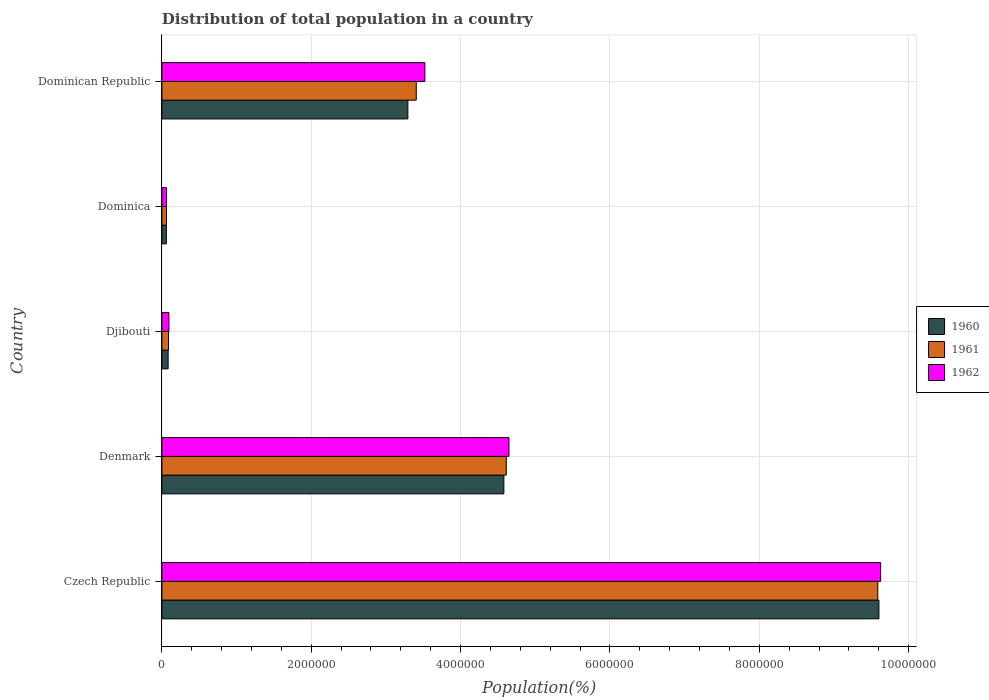How many groups of bars are there?
Give a very brief answer. 5. How many bars are there on the 3rd tick from the top?
Offer a very short reply. 3. How many bars are there on the 3rd tick from the bottom?
Offer a terse response. 3. What is the label of the 2nd group of bars from the top?
Provide a succinct answer. Dominica. What is the population of in 1962 in Czech Republic?
Your answer should be compact. 9.62e+06. Across all countries, what is the maximum population of in 1960?
Provide a succinct answer. 9.60e+06. Across all countries, what is the minimum population of in 1961?
Provide a short and direct response. 6.10e+04. In which country was the population of in 1962 maximum?
Give a very brief answer. Czech Republic. In which country was the population of in 1960 minimum?
Offer a terse response. Dominica. What is the total population of in 1961 in the graph?
Give a very brief answer. 1.78e+07. What is the difference between the population of in 1962 in Denmark and that in Dominican Republic?
Keep it short and to the point. 1.13e+06. What is the difference between the population of in 1962 in Djibouti and the population of in 1960 in Dominican Republic?
Keep it short and to the point. -3.20e+06. What is the average population of in 1962 per country?
Your response must be concise. 3.59e+06. What is the difference between the population of in 1961 and population of in 1960 in Dominica?
Your answer should be compact. 1019. What is the ratio of the population of in 1961 in Czech Republic to that in Dominican Republic?
Offer a terse response. 2.81. Is the population of in 1960 in Czech Republic less than that in Djibouti?
Offer a very short reply. No. Is the difference between the population of in 1961 in Czech Republic and Denmark greater than the difference between the population of in 1960 in Czech Republic and Denmark?
Your response must be concise. No. What is the difference between the highest and the second highest population of in 1961?
Keep it short and to the point. 4.97e+06. What is the difference between the highest and the lowest population of in 1962?
Offer a very short reply. 9.56e+06. In how many countries, is the population of in 1961 greater than the average population of in 1961 taken over all countries?
Your response must be concise. 2. What does the 3rd bar from the top in Denmark represents?
Provide a short and direct response. 1960. What does the 2nd bar from the bottom in Djibouti represents?
Offer a very short reply. 1961. Is it the case that in every country, the sum of the population of in 1962 and population of in 1961 is greater than the population of in 1960?
Make the answer very short. Yes. How many bars are there?
Give a very brief answer. 15. How many countries are there in the graph?
Offer a terse response. 5. Where does the legend appear in the graph?
Make the answer very short. Center right. What is the title of the graph?
Offer a terse response. Distribution of total population in a country. What is the label or title of the X-axis?
Provide a succinct answer. Population(%). What is the Population(%) of 1960 in Czech Republic?
Provide a succinct answer. 9.60e+06. What is the Population(%) in 1961 in Czech Republic?
Keep it short and to the point. 9.59e+06. What is the Population(%) of 1962 in Czech Republic?
Your answer should be compact. 9.62e+06. What is the Population(%) of 1960 in Denmark?
Offer a very short reply. 4.58e+06. What is the Population(%) in 1961 in Denmark?
Give a very brief answer. 4.61e+06. What is the Population(%) of 1962 in Denmark?
Provide a succinct answer. 4.65e+06. What is the Population(%) of 1960 in Djibouti?
Provide a succinct answer. 8.36e+04. What is the Population(%) of 1961 in Djibouti?
Offer a terse response. 8.85e+04. What is the Population(%) of 1962 in Djibouti?
Provide a succinct answer. 9.42e+04. What is the Population(%) in 1960 in Dominica?
Provide a succinct answer. 6.00e+04. What is the Population(%) of 1961 in Dominica?
Offer a very short reply. 6.10e+04. What is the Population(%) of 1962 in Dominica?
Offer a very short reply. 6.20e+04. What is the Population(%) of 1960 in Dominican Republic?
Provide a succinct answer. 3.29e+06. What is the Population(%) in 1961 in Dominican Republic?
Give a very brief answer. 3.41e+06. What is the Population(%) of 1962 in Dominican Republic?
Offer a terse response. 3.52e+06. Across all countries, what is the maximum Population(%) in 1960?
Offer a very short reply. 9.60e+06. Across all countries, what is the maximum Population(%) of 1961?
Keep it short and to the point. 9.59e+06. Across all countries, what is the maximum Population(%) in 1962?
Provide a succinct answer. 9.62e+06. Across all countries, what is the minimum Population(%) of 1960?
Give a very brief answer. 6.00e+04. Across all countries, what is the minimum Population(%) of 1961?
Make the answer very short. 6.10e+04. Across all countries, what is the minimum Population(%) of 1962?
Keep it short and to the point. 6.20e+04. What is the total Population(%) of 1960 in the graph?
Keep it short and to the point. 1.76e+07. What is the total Population(%) in 1961 in the graph?
Your answer should be very brief. 1.78e+07. What is the total Population(%) of 1962 in the graph?
Your response must be concise. 1.79e+07. What is the difference between the Population(%) of 1960 in Czech Republic and that in Denmark?
Ensure brevity in your answer.  5.02e+06. What is the difference between the Population(%) of 1961 in Czech Republic and that in Denmark?
Offer a terse response. 4.97e+06. What is the difference between the Population(%) in 1962 in Czech Republic and that in Denmark?
Give a very brief answer. 4.98e+06. What is the difference between the Population(%) of 1960 in Czech Republic and that in Djibouti?
Keep it short and to the point. 9.52e+06. What is the difference between the Population(%) of 1961 in Czech Republic and that in Djibouti?
Provide a succinct answer. 9.50e+06. What is the difference between the Population(%) of 1962 in Czech Republic and that in Djibouti?
Offer a very short reply. 9.53e+06. What is the difference between the Population(%) in 1960 in Czech Republic and that in Dominica?
Offer a very short reply. 9.54e+06. What is the difference between the Population(%) of 1961 in Czech Republic and that in Dominica?
Your response must be concise. 9.53e+06. What is the difference between the Population(%) of 1962 in Czech Republic and that in Dominica?
Keep it short and to the point. 9.56e+06. What is the difference between the Population(%) of 1960 in Czech Republic and that in Dominican Republic?
Your answer should be compact. 6.31e+06. What is the difference between the Population(%) of 1961 in Czech Republic and that in Dominican Republic?
Keep it short and to the point. 6.18e+06. What is the difference between the Population(%) of 1962 in Czech Republic and that in Dominican Republic?
Keep it short and to the point. 6.10e+06. What is the difference between the Population(%) of 1960 in Denmark and that in Djibouti?
Make the answer very short. 4.50e+06. What is the difference between the Population(%) of 1961 in Denmark and that in Djibouti?
Ensure brevity in your answer.  4.52e+06. What is the difference between the Population(%) of 1962 in Denmark and that in Djibouti?
Keep it short and to the point. 4.55e+06. What is the difference between the Population(%) in 1960 in Denmark and that in Dominica?
Make the answer very short. 4.52e+06. What is the difference between the Population(%) in 1961 in Denmark and that in Dominica?
Provide a short and direct response. 4.55e+06. What is the difference between the Population(%) in 1962 in Denmark and that in Dominica?
Your response must be concise. 4.59e+06. What is the difference between the Population(%) in 1960 in Denmark and that in Dominican Republic?
Ensure brevity in your answer.  1.29e+06. What is the difference between the Population(%) of 1961 in Denmark and that in Dominican Republic?
Your answer should be very brief. 1.21e+06. What is the difference between the Population(%) in 1962 in Denmark and that in Dominican Republic?
Your answer should be very brief. 1.13e+06. What is the difference between the Population(%) in 1960 in Djibouti and that in Dominica?
Give a very brief answer. 2.36e+04. What is the difference between the Population(%) in 1961 in Djibouti and that in Dominica?
Offer a terse response. 2.75e+04. What is the difference between the Population(%) in 1962 in Djibouti and that in Dominica?
Offer a very short reply. 3.22e+04. What is the difference between the Population(%) in 1960 in Djibouti and that in Dominican Republic?
Your response must be concise. -3.21e+06. What is the difference between the Population(%) of 1961 in Djibouti and that in Dominican Republic?
Make the answer very short. -3.32e+06. What is the difference between the Population(%) of 1962 in Djibouti and that in Dominican Republic?
Give a very brief answer. -3.43e+06. What is the difference between the Population(%) of 1960 in Dominica and that in Dominican Republic?
Offer a very short reply. -3.23e+06. What is the difference between the Population(%) of 1961 in Dominica and that in Dominican Republic?
Your answer should be very brief. -3.35e+06. What is the difference between the Population(%) of 1962 in Dominica and that in Dominican Republic?
Give a very brief answer. -3.46e+06. What is the difference between the Population(%) of 1960 in Czech Republic and the Population(%) of 1961 in Denmark?
Keep it short and to the point. 4.99e+06. What is the difference between the Population(%) of 1960 in Czech Republic and the Population(%) of 1962 in Denmark?
Ensure brevity in your answer.  4.95e+06. What is the difference between the Population(%) of 1961 in Czech Republic and the Population(%) of 1962 in Denmark?
Offer a terse response. 4.94e+06. What is the difference between the Population(%) of 1960 in Czech Republic and the Population(%) of 1961 in Djibouti?
Provide a short and direct response. 9.51e+06. What is the difference between the Population(%) in 1960 in Czech Republic and the Population(%) in 1962 in Djibouti?
Offer a terse response. 9.51e+06. What is the difference between the Population(%) in 1961 in Czech Republic and the Population(%) in 1962 in Djibouti?
Your response must be concise. 9.49e+06. What is the difference between the Population(%) in 1960 in Czech Republic and the Population(%) in 1961 in Dominica?
Ensure brevity in your answer.  9.54e+06. What is the difference between the Population(%) of 1960 in Czech Republic and the Population(%) of 1962 in Dominica?
Make the answer very short. 9.54e+06. What is the difference between the Population(%) in 1961 in Czech Republic and the Population(%) in 1962 in Dominica?
Make the answer very short. 9.52e+06. What is the difference between the Population(%) of 1960 in Czech Republic and the Population(%) of 1961 in Dominican Republic?
Your answer should be very brief. 6.20e+06. What is the difference between the Population(%) of 1960 in Czech Republic and the Population(%) of 1962 in Dominican Republic?
Your answer should be very brief. 6.08e+06. What is the difference between the Population(%) in 1961 in Czech Republic and the Population(%) in 1962 in Dominican Republic?
Keep it short and to the point. 6.07e+06. What is the difference between the Population(%) of 1960 in Denmark and the Population(%) of 1961 in Djibouti?
Offer a terse response. 4.49e+06. What is the difference between the Population(%) of 1960 in Denmark and the Population(%) of 1962 in Djibouti?
Offer a very short reply. 4.49e+06. What is the difference between the Population(%) in 1961 in Denmark and the Population(%) in 1962 in Djibouti?
Provide a short and direct response. 4.52e+06. What is the difference between the Population(%) in 1960 in Denmark and the Population(%) in 1961 in Dominica?
Your answer should be very brief. 4.52e+06. What is the difference between the Population(%) in 1960 in Denmark and the Population(%) in 1962 in Dominica?
Give a very brief answer. 4.52e+06. What is the difference between the Population(%) in 1961 in Denmark and the Population(%) in 1962 in Dominica?
Make the answer very short. 4.55e+06. What is the difference between the Population(%) of 1960 in Denmark and the Population(%) of 1961 in Dominican Republic?
Your response must be concise. 1.17e+06. What is the difference between the Population(%) of 1960 in Denmark and the Population(%) of 1962 in Dominican Republic?
Give a very brief answer. 1.06e+06. What is the difference between the Population(%) in 1961 in Denmark and the Population(%) in 1962 in Dominican Republic?
Offer a terse response. 1.09e+06. What is the difference between the Population(%) of 1960 in Djibouti and the Population(%) of 1961 in Dominica?
Provide a succinct answer. 2.26e+04. What is the difference between the Population(%) of 1960 in Djibouti and the Population(%) of 1962 in Dominica?
Your answer should be compact. 2.17e+04. What is the difference between the Population(%) of 1961 in Djibouti and the Population(%) of 1962 in Dominica?
Offer a very short reply. 2.65e+04. What is the difference between the Population(%) of 1960 in Djibouti and the Population(%) of 1961 in Dominican Republic?
Provide a succinct answer. -3.32e+06. What is the difference between the Population(%) of 1960 in Djibouti and the Population(%) of 1962 in Dominican Republic?
Give a very brief answer. -3.44e+06. What is the difference between the Population(%) in 1961 in Djibouti and the Population(%) in 1962 in Dominican Republic?
Your response must be concise. -3.43e+06. What is the difference between the Population(%) of 1960 in Dominica and the Population(%) of 1961 in Dominican Republic?
Ensure brevity in your answer.  -3.35e+06. What is the difference between the Population(%) of 1960 in Dominica and the Population(%) of 1962 in Dominican Republic?
Provide a short and direct response. -3.46e+06. What is the difference between the Population(%) of 1961 in Dominica and the Population(%) of 1962 in Dominican Republic?
Keep it short and to the point. -3.46e+06. What is the average Population(%) in 1960 per country?
Offer a terse response. 3.52e+06. What is the average Population(%) of 1961 per country?
Your answer should be compact. 3.55e+06. What is the average Population(%) in 1962 per country?
Ensure brevity in your answer.  3.59e+06. What is the difference between the Population(%) in 1960 and Population(%) in 1961 in Czech Republic?
Provide a succinct answer. 1.54e+04. What is the difference between the Population(%) of 1960 and Population(%) of 1962 in Czech Republic?
Your response must be concise. -2.27e+04. What is the difference between the Population(%) of 1961 and Population(%) of 1962 in Czech Republic?
Offer a terse response. -3.80e+04. What is the difference between the Population(%) in 1960 and Population(%) in 1961 in Denmark?
Offer a very short reply. -3.21e+04. What is the difference between the Population(%) of 1960 and Population(%) of 1962 in Denmark?
Provide a short and direct response. -6.81e+04. What is the difference between the Population(%) of 1961 and Population(%) of 1962 in Denmark?
Your response must be concise. -3.60e+04. What is the difference between the Population(%) in 1960 and Population(%) in 1961 in Djibouti?
Your answer should be compact. -4863. What is the difference between the Population(%) of 1960 and Population(%) of 1962 in Djibouti?
Your answer should be very brief. -1.06e+04. What is the difference between the Population(%) of 1961 and Population(%) of 1962 in Djibouti?
Keep it short and to the point. -5701. What is the difference between the Population(%) of 1960 and Population(%) of 1961 in Dominica?
Ensure brevity in your answer.  -1019. What is the difference between the Population(%) in 1960 and Population(%) in 1962 in Dominica?
Ensure brevity in your answer.  -1968. What is the difference between the Population(%) in 1961 and Population(%) in 1962 in Dominica?
Make the answer very short. -949. What is the difference between the Population(%) of 1960 and Population(%) of 1961 in Dominican Republic?
Offer a very short reply. -1.12e+05. What is the difference between the Population(%) in 1960 and Population(%) in 1962 in Dominican Republic?
Provide a short and direct response. -2.27e+05. What is the difference between the Population(%) of 1961 and Population(%) of 1962 in Dominican Republic?
Your answer should be compact. -1.15e+05. What is the ratio of the Population(%) in 1960 in Czech Republic to that in Denmark?
Keep it short and to the point. 2.1. What is the ratio of the Population(%) of 1961 in Czech Republic to that in Denmark?
Provide a succinct answer. 2.08. What is the ratio of the Population(%) in 1962 in Czech Republic to that in Denmark?
Keep it short and to the point. 2.07. What is the ratio of the Population(%) in 1960 in Czech Republic to that in Djibouti?
Provide a succinct answer. 114.81. What is the ratio of the Population(%) in 1961 in Czech Republic to that in Djibouti?
Provide a succinct answer. 108.33. What is the ratio of the Population(%) in 1962 in Czech Republic to that in Djibouti?
Your response must be concise. 102.17. What is the ratio of the Population(%) of 1960 in Czech Republic to that in Dominica?
Offer a terse response. 159.99. What is the ratio of the Population(%) of 1961 in Czech Republic to that in Dominica?
Keep it short and to the point. 157.07. What is the ratio of the Population(%) of 1962 in Czech Republic to that in Dominica?
Provide a short and direct response. 155.28. What is the ratio of the Population(%) in 1960 in Czech Republic to that in Dominican Republic?
Provide a short and direct response. 2.92. What is the ratio of the Population(%) of 1961 in Czech Republic to that in Dominican Republic?
Your answer should be very brief. 2.81. What is the ratio of the Population(%) in 1962 in Czech Republic to that in Dominican Republic?
Provide a short and direct response. 2.73. What is the ratio of the Population(%) of 1960 in Denmark to that in Djibouti?
Your response must be concise. 54.76. What is the ratio of the Population(%) of 1961 in Denmark to that in Djibouti?
Ensure brevity in your answer.  52.11. What is the ratio of the Population(%) of 1962 in Denmark to that in Djibouti?
Keep it short and to the point. 49.34. What is the ratio of the Population(%) in 1960 in Denmark to that in Dominica?
Your answer should be very brief. 76.31. What is the ratio of the Population(%) of 1961 in Denmark to that in Dominica?
Provide a short and direct response. 75.56. What is the ratio of the Population(%) in 1962 in Denmark to that in Dominica?
Give a very brief answer. 74.98. What is the ratio of the Population(%) of 1960 in Denmark to that in Dominican Republic?
Keep it short and to the point. 1.39. What is the ratio of the Population(%) in 1961 in Denmark to that in Dominican Republic?
Offer a terse response. 1.35. What is the ratio of the Population(%) of 1962 in Denmark to that in Dominican Republic?
Provide a succinct answer. 1.32. What is the ratio of the Population(%) in 1960 in Djibouti to that in Dominica?
Make the answer very short. 1.39. What is the ratio of the Population(%) of 1961 in Djibouti to that in Dominica?
Provide a short and direct response. 1.45. What is the ratio of the Population(%) of 1962 in Djibouti to that in Dominica?
Your answer should be very brief. 1.52. What is the ratio of the Population(%) in 1960 in Djibouti to that in Dominican Republic?
Keep it short and to the point. 0.03. What is the ratio of the Population(%) of 1961 in Djibouti to that in Dominican Republic?
Ensure brevity in your answer.  0.03. What is the ratio of the Population(%) in 1962 in Djibouti to that in Dominican Republic?
Your answer should be very brief. 0.03. What is the ratio of the Population(%) in 1960 in Dominica to that in Dominican Republic?
Give a very brief answer. 0.02. What is the ratio of the Population(%) of 1961 in Dominica to that in Dominican Republic?
Provide a succinct answer. 0.02. What is the ratio of the Population(%) of 1962 in Dominica to that in Dominican Republic?
Keep it short and to the point. 0.02. What is the difference between the highest and the second highest Population(%) of 1960?
Provide a succinct answer. 5.02e+06. What is the difference between the highest and the second highest Population(%) in 1961?
Offer a terse response. 4.97e+06. What is the difference between the highest and the second highest Population(%) in 1962?
Ensure brevity in your answer.  4.98e+06. What is the difference between the highest and the lowest Population(%) of 1960?
Provide a short and direct response. 9.54e+06. What is the difference between the highest and the lowest Population(%) in 1961?
Ensure brevity in your answer.  9.53e+06. What is the difference between the highest and the lowest Population(%) of 1962?
Keep it short and to the point. 9.56e+06. 